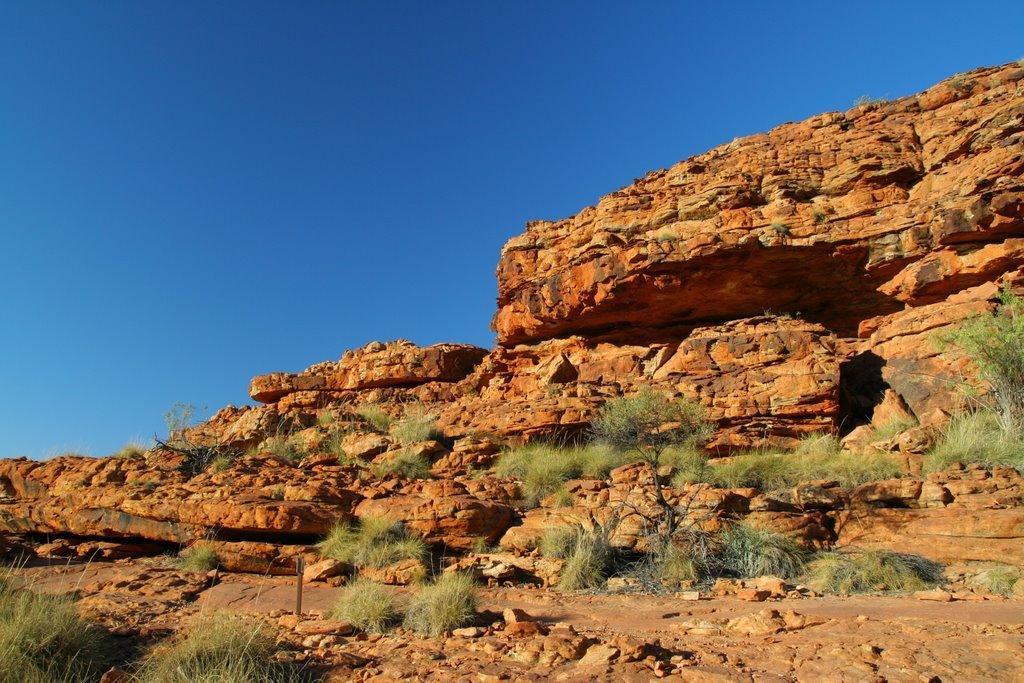In one or two sentences, can you explain what this image depicts? In this picture we can see mountain, stone and trees. On the top there is a sky. 